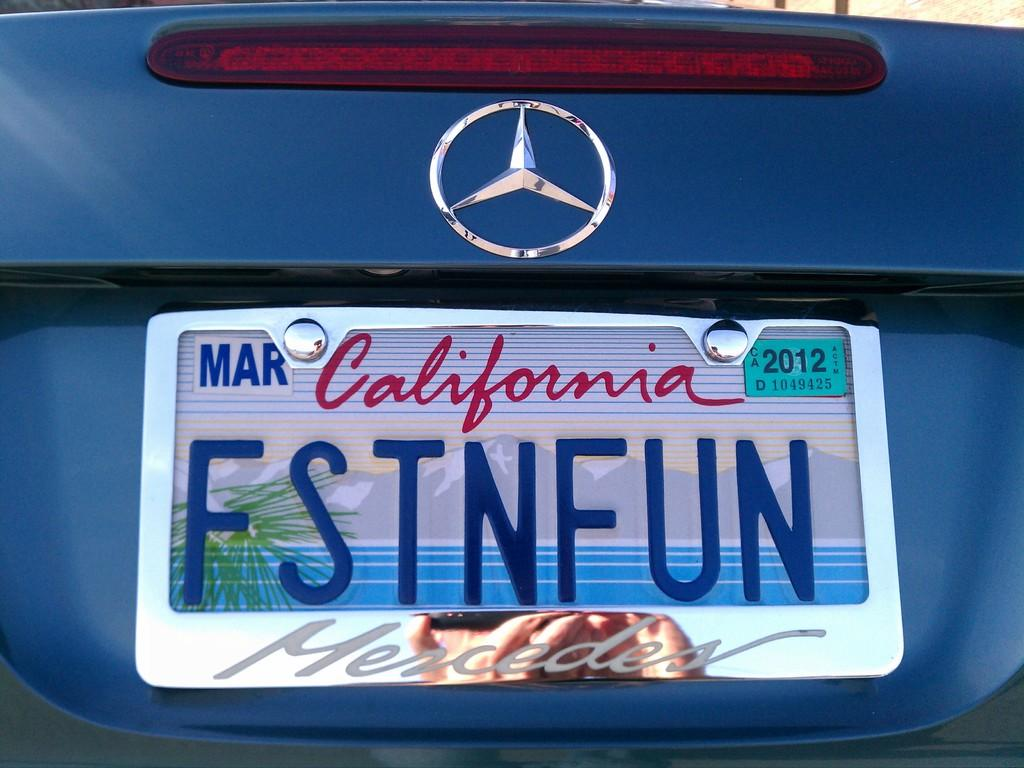What is the main subject of the image? The main subject of the image is a car. Can you describe any specific features of the car? The car has a number plate. What type of amusement can be seen on the face of the car in the image? There is no face present on the car in the image, so it cannot be determined if there is any amusement. 